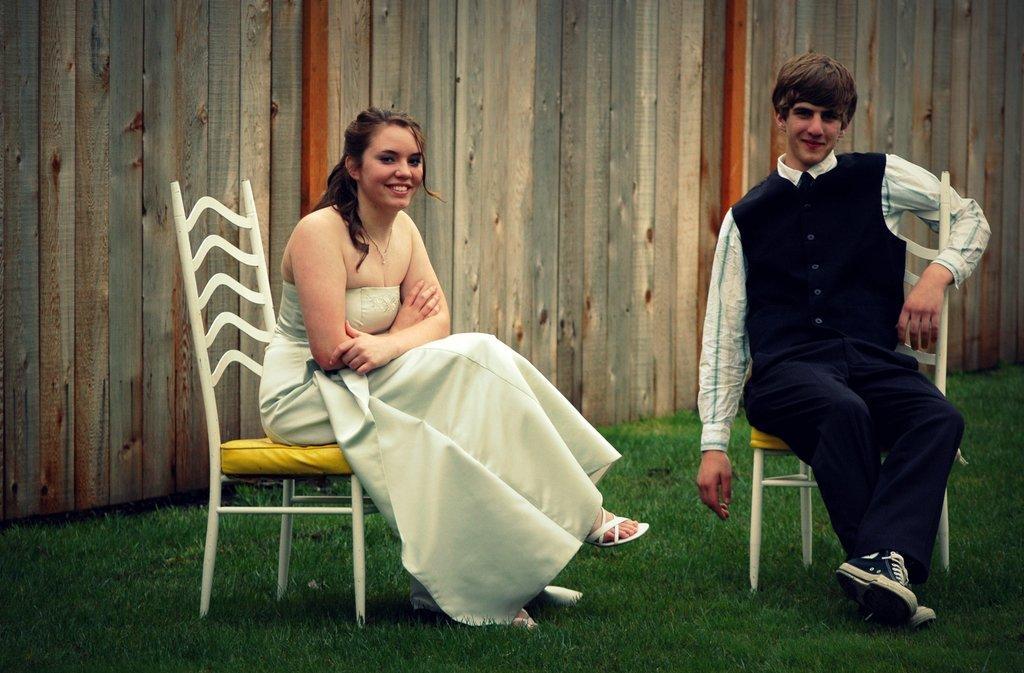Could you give a brief overview of what you see in this image? In this image, we can see 2 people are sat on the chair. On the left side, the women wear a white color dress. And right side, a man wear a shirt and pant and coat. Here we can see coat buttons. At the background, we can see a wooden fencing. And the bottom of the image, we can see a grass. 